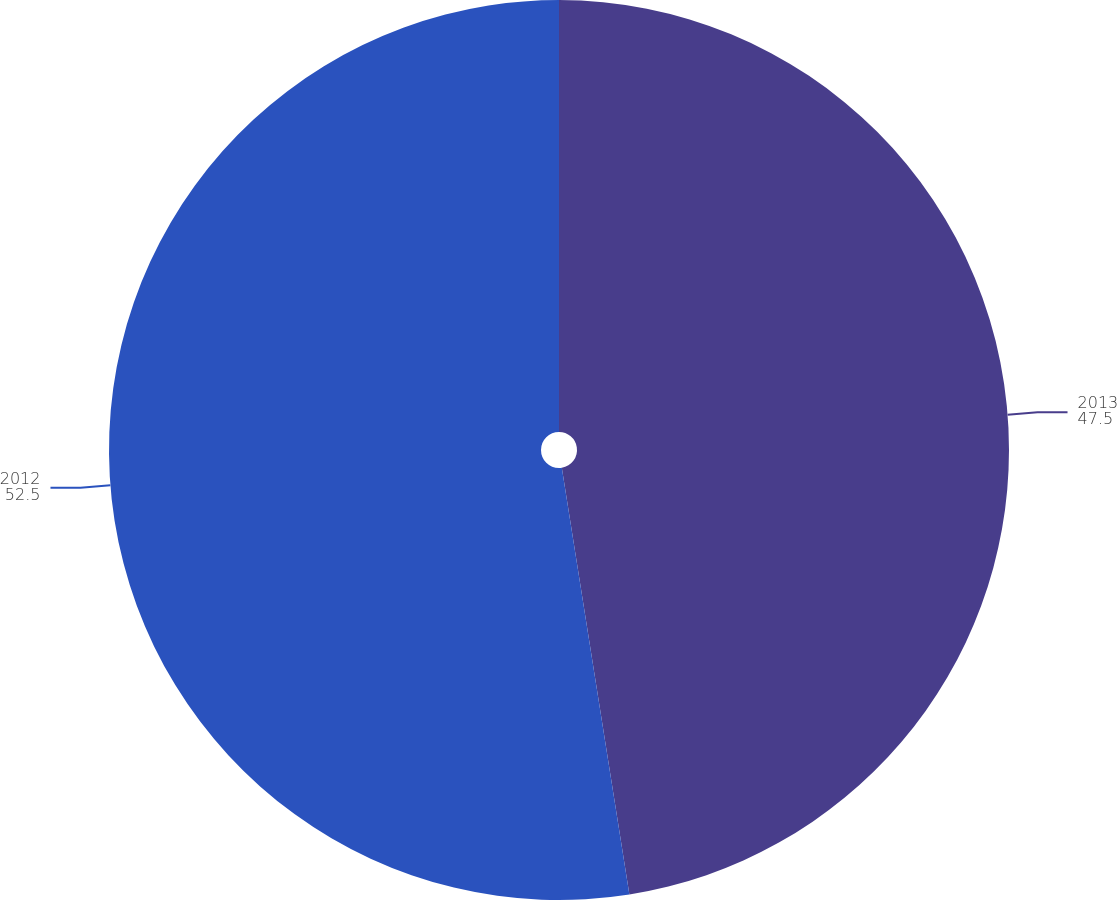<chart> <loc_0><loc_0><loc_500><loc_500><pie_chart><fcel>2013<fcel>2012<nl><fcel>47.5%<fcel>52.5%<nl></chart> 